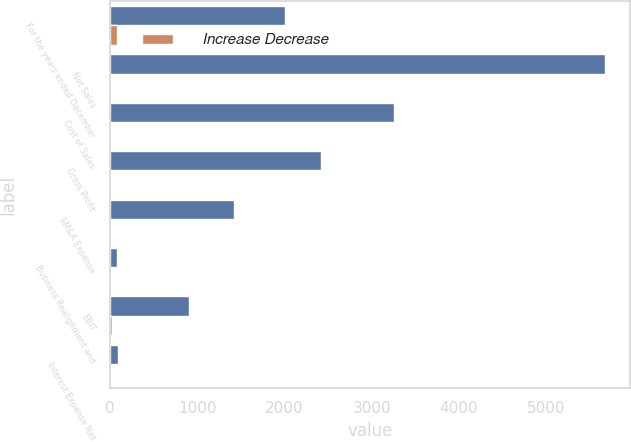Convert chart. <chart><loc_0><loc_0><loc_500><loc_500><stacked_bar_chart><ecel><fcel>For the years ended December<fcel>Net Sales<fcel>Cost of Sales<fcel>Gross Profit<fcel>SM&A Expense<fcel>Business Realignment and<fcel>EBIT<fcel>Interest Expense Net<nl><fcel>nan<fcel>2010<fcel>5671<fcel>3255.8<fcel>2415.2<fcel>1426.5<fcel>83.4<fcel>905.3<fcel>96.4<nl><fcel>Increase Decrease<fcel>83.4<fcel>7<fcel>0.3<fcel>17.6<fcel>18<fcel>0.7<fcel>18.9<fcel>6.6<nl></chart> 